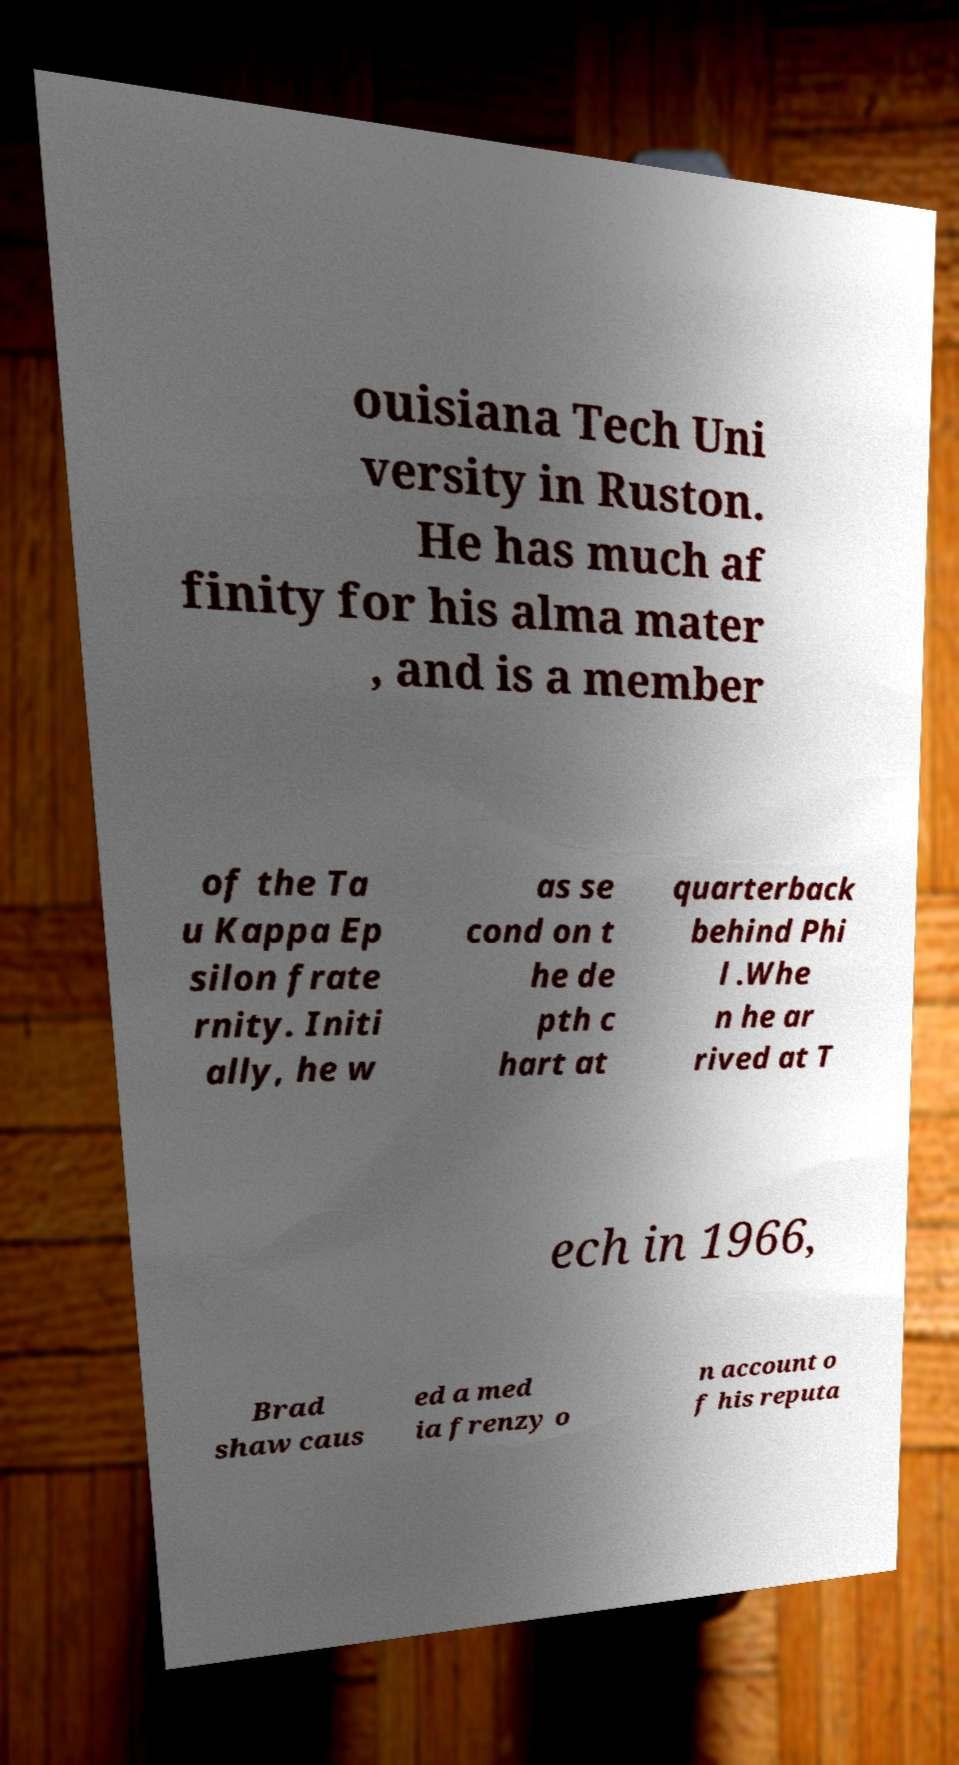I need the written content from this picture converted into text. Can you do that? ouisiana Tech Uni versity in Ruston. He has much af finity for his alma mater , and is a member of the Ta u Kappa Ep silon frate rnity. Initi ally, he w as se cond on t he de pth c hart at quarterback behind Phi l .Whe n he ar rived at T ech in 1966, Brad shaw caus ed a med ia frenzy o n account o f his reputa 